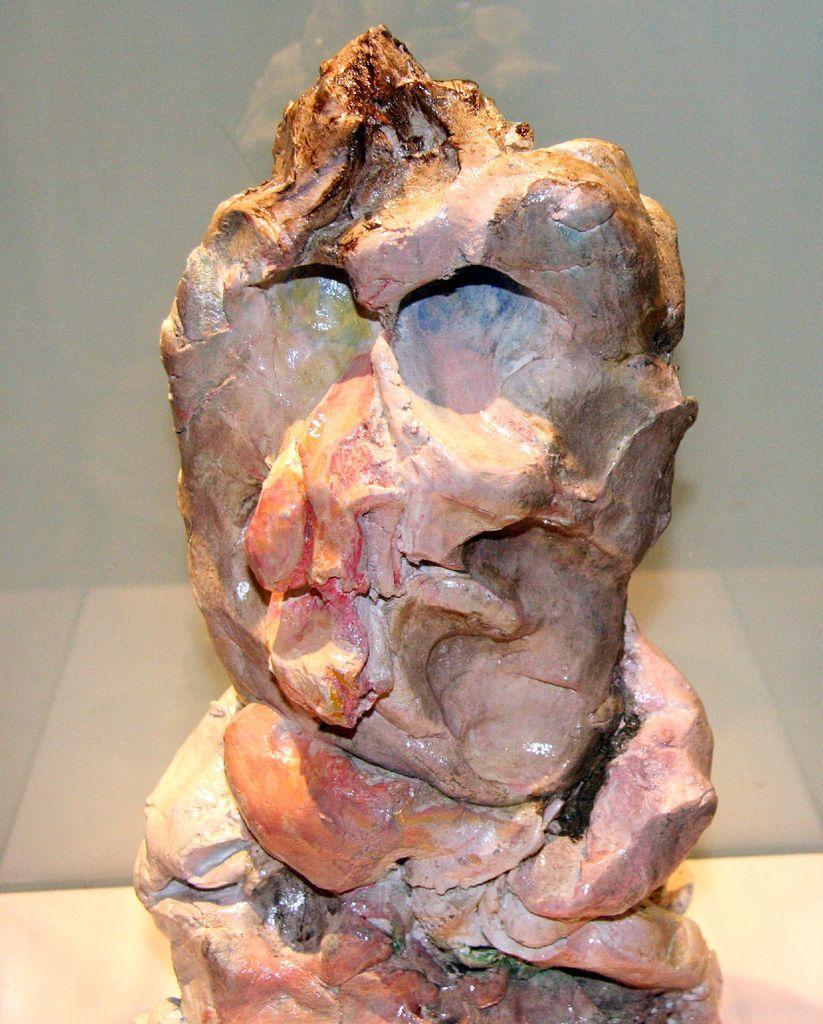In one or two sentences, can you explain what this image depicts? In this image we can see an object which looks like a sculpture. Behind the sculpture, we can see the wall. 